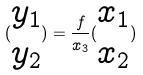Convert formula to latex. <formula><loc_0><loc_0><loc_500><loc_500>( \begin{matrix} y _ { 1 } \\ y _ { 2 } \end{matrix} ) = \frac { f } { x _ { 3 } } ( \begin{matrix} x _ { 1 } \\ x _ { 2 } \end{matrix} )</formula> 